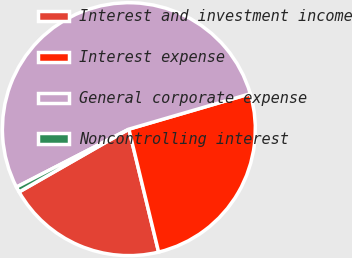<chart> <loc_0><loc_0><loc_500><loc_500><pie_chart><fcel>Interest and investment income<fcel>Interest expense<fcel>General corporate expense<fcel>Noncontrolling interest<nl><fcel>20.51%<fcel>25.74%<fcel>53.05%<fcel>0.7%<nl></chart> 